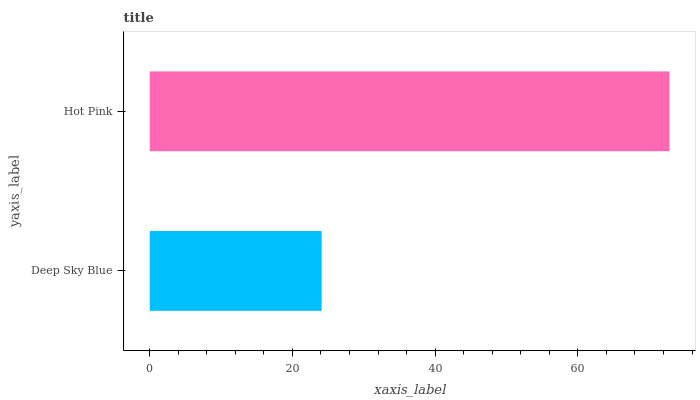Is Deep Sky Blue the minimum?
Answer yes or no. Yes. Is Hot Pink the maximum?
Answer yes or no. Yes. Is Hot Pink the minimum?
Answer yes or no. No. Is Hot Pink greater than Deep Sky Blue?
Answer yes or no. Yes. Is Deep Sky Blue less than Hot Pink?
Answer yes or no. Yes. Is Deep Sky Blue greater than Hot Pink?
Answer yes or no. No. Is Hot Pink less than Deep Sky Blue?
Answer yes or no. No. Is Hot Pink the high median?
Answer yes or no. Yes. Is Deep Sky Blue the low median?
Answer yes or no. Yes. Is Deep Sky Blue the high median?
Answer yes or no. No. Is Hot Pink the low median?
Answer yes or no. No. 